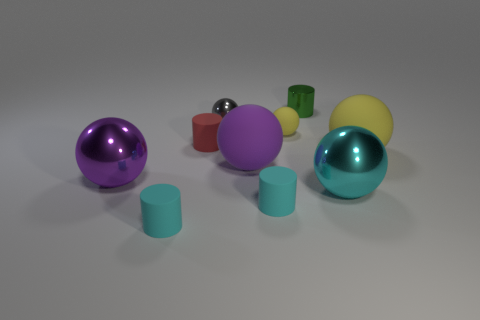Subtract all gray spheres. How many spheres are left? 5 Subtract all small yellow balls. How many balls are left? 5 Subtract 2 spheres. How many spheres are left? 4 Subtract all yellow balls. Subtract all purple cylinders. How many balls are left? 4 Subtract all balls. How many objects are left? 4 Add 9 gray metal objects. How many gray metal objects are left? 10 Add 5 large purple shiny things. How many large purple shiny things exist? 6 Subtract 0 red balls. How many objects are left? 10 Subtract all tiny red matte things. Subtract all tiny matte objects. How many objects are left? 5 